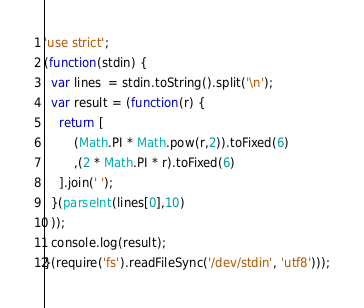Convert code to text. <code><loc_0><loc_0><loc_500><loc_500><_JavaScript_>'use strict';
(function(stdin) {
  var lines  = stdin.toString().split('\n');
  var result = (function(r) {
  	return [
  		(Math.PI * Math.pow(r,2)).toFixed(6)
  		,(2 * Math.PI * r).toFixed(6)
  	].join(' ');
  }(parseInt(lines[0],10)
  ));
  console.log(result);
}(require('fs').readFileSync('/dev/stdin', 'utf8')));</code> 